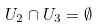Convert formula to latex. <formula><loc_0><loc_0><loc_500><loc_500>U _ { 2 } \cap U _ { 3 } = \emptyset</formula> 